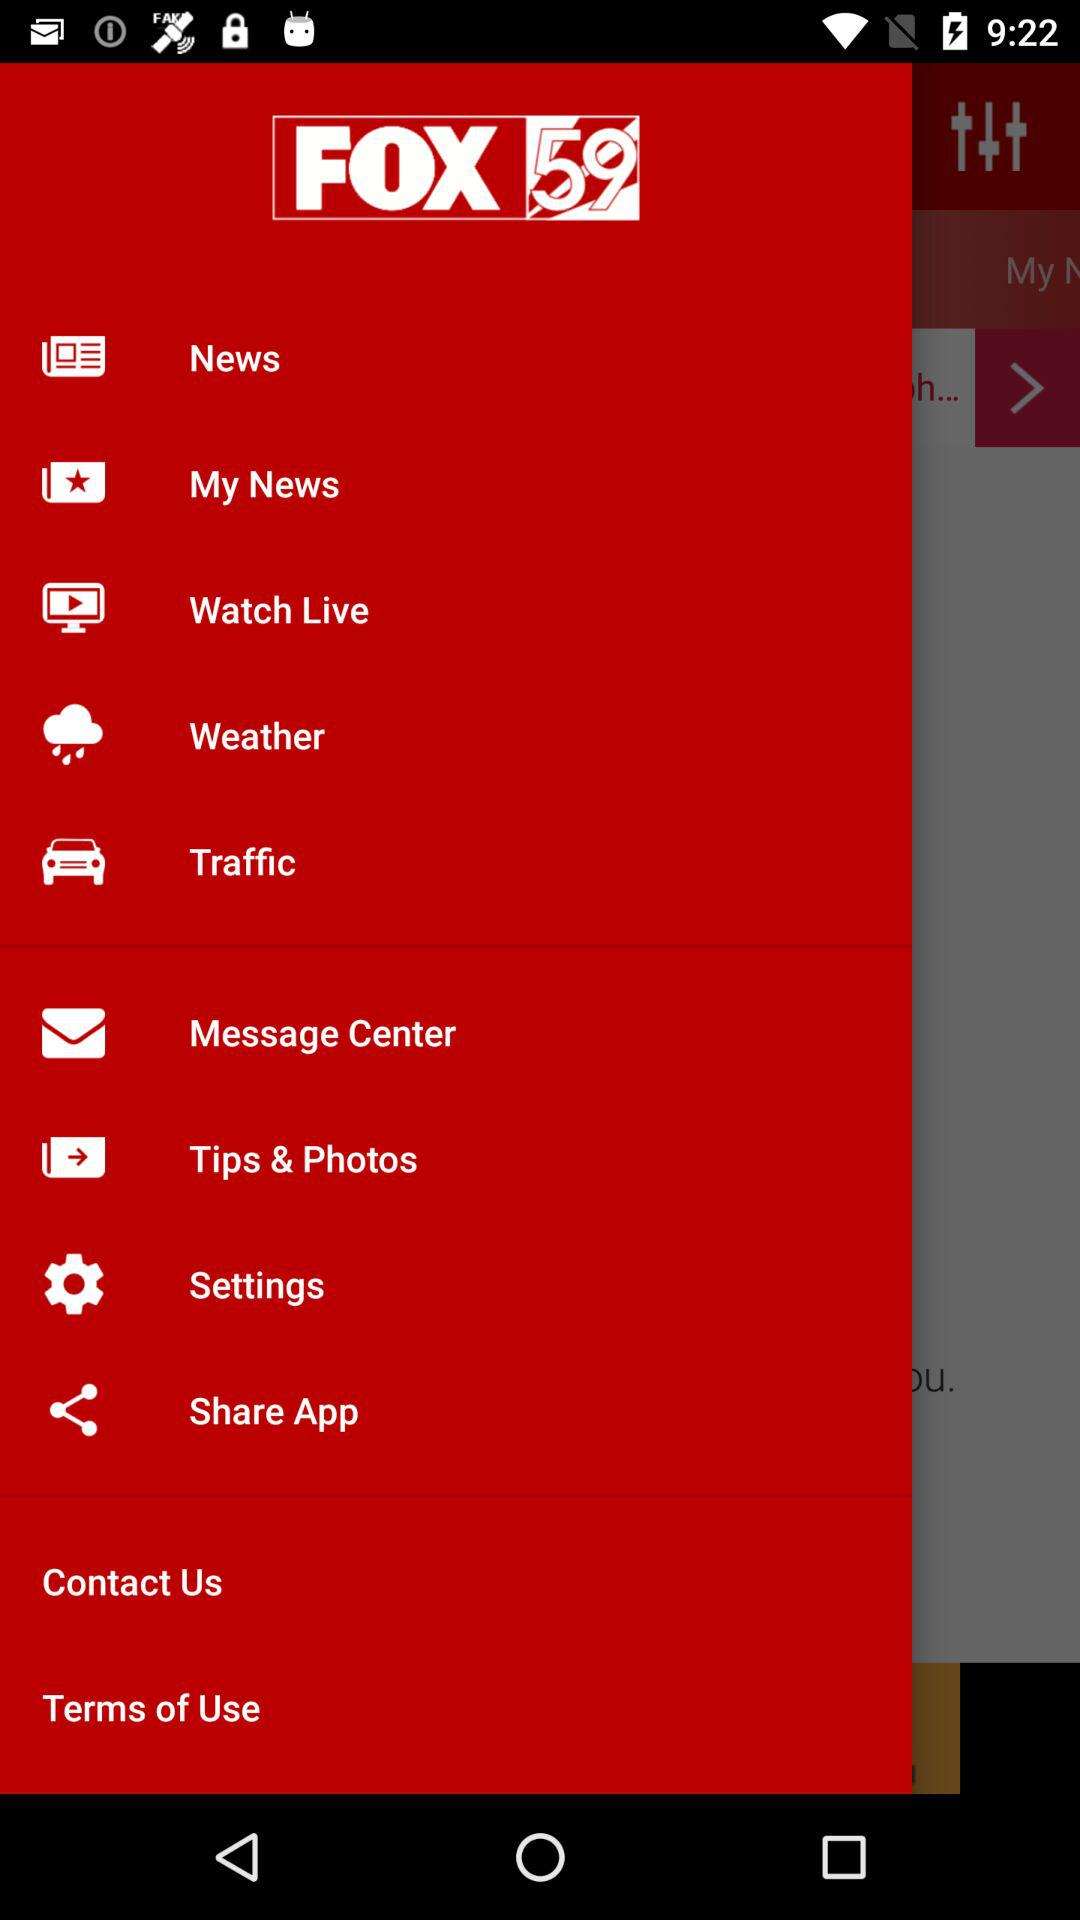Which option has been selected?
When the provided information is insufficient, respond with <no answer>. <no answer> 